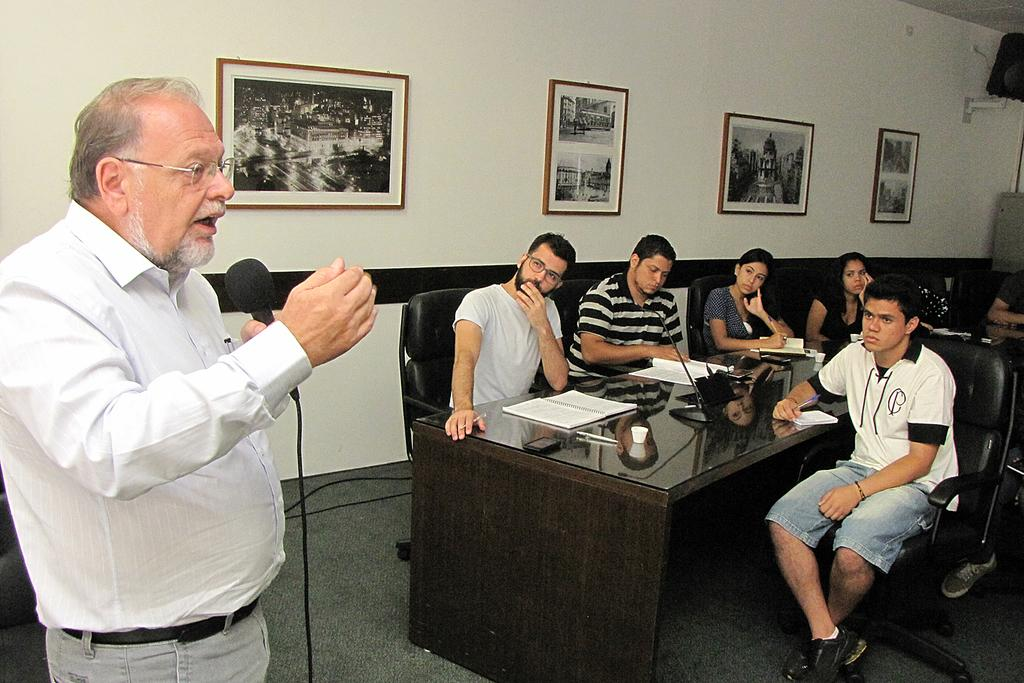What are the people in the image doing? The people in the image are sitting around a table. What are the people sitting on? The people are sitting on chairs. What is the man on the left side of the image doing? The man is standing on the left side of the image and talking on a microphone. How many photo frames are on the wall in the image? There are four photo frames on the wall. What country is the man talking about in the image? The image does not provide any information about the country being discussed. What channel is the man using to talk on the microphone? The image does not provide any information about the channel being used for the microphone. 